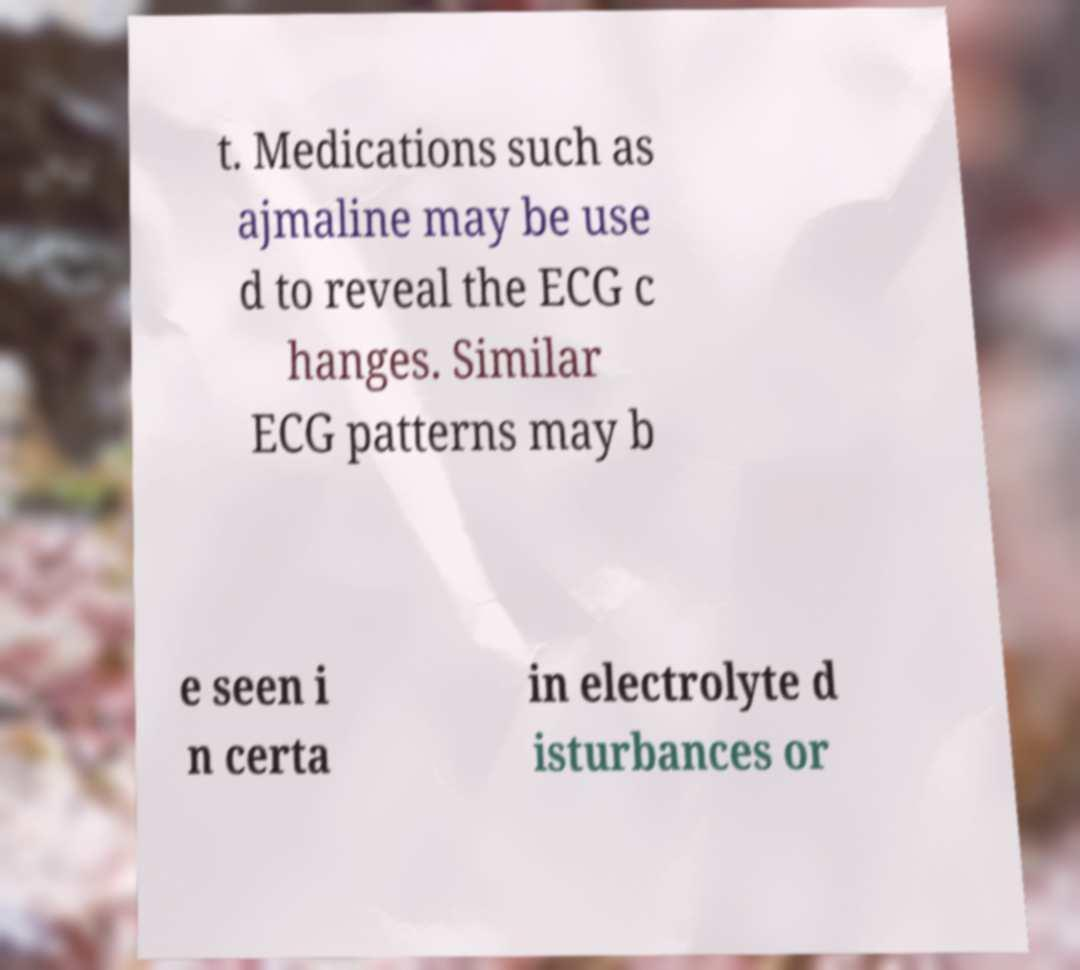What messages or text are displayed in this image? I need them in a readable, typed format. t. Medications such as ajmaline may be use d to reveal the ECG c hanges. Similar ECG patterns may b e seen i n certa in electrolyte d isturbances or 